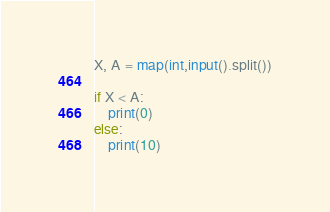Convert code to text. <code><loc_0><loc_0><loc_500><loc_500><_Python_>X, A = map(int,input().split())

if X < A:
    print(0)
else:
    print(10)</code> 